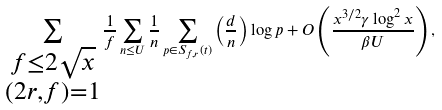Convert formula to latex. <formula><loc_0><loc_0><loc_500><loc_500>\sum _ { \substack { f \leq 2 \sqrt { x } \\ ( 2 r , f ) = 1 } } \frac { 1 } { f } \sum _ { n \leq U } \frac { 1 } { n } \sum _ { p \in S _ { f , r } ( t ) } \left ( \frac { d } { n } \right ) \log p + O \left ( \frac { x ^ { 3 / 2 } \gamma \log ^ { 2 } x } { \beta U } \right ) ,</formula> 